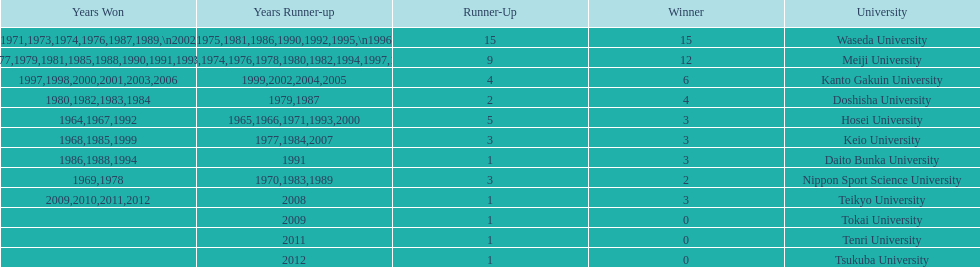Which university had the most years won? Waseda University. 